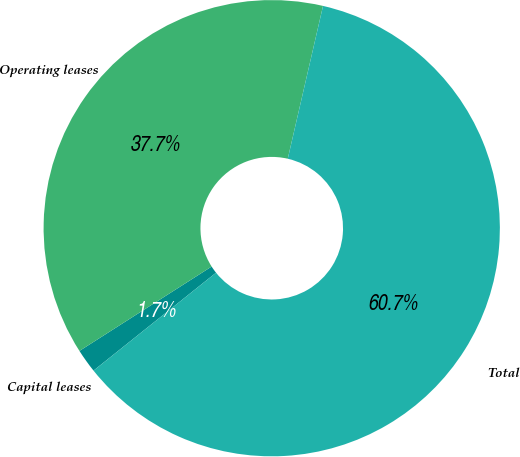Convert chart to OTSL. <chart><loc_0><loc_0><loc_500><loc_500><pie_chart><fcel>Capital leases<fcel>Operating leases<fcel>Total<nl><fcel>1.69%<fcel>37.65%<fcel>60.66%<nl></chart> 